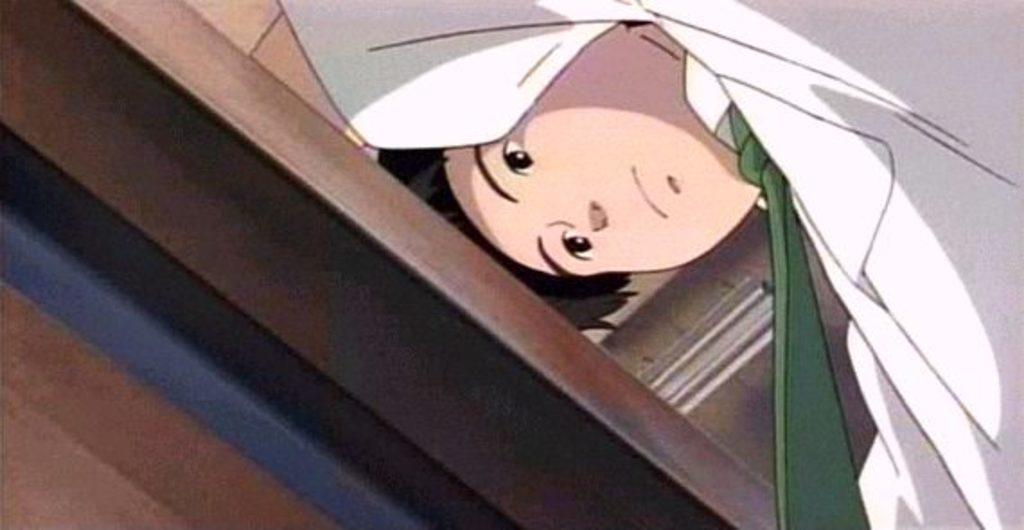What type of image is being described? The image is a cartoon. Who is the main character in the image? There is a boy in the image. What is the boy wearing? The boy is wearing a white shirt. Are there any additional details about the boy's shirt? Yes, the boy's shirt has a green tie. What is the name of the star that the boy is trying to reach in the image? There is no star present in the image, and the boy is not trying to reach any star. 